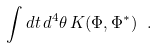<formula> <loc_0><loc_0><loc_500><loc_500>\int d t \, d ^ { 4 } \theta \, K ( \Phi , \Phi ^ { * } ) \ .</formula> 